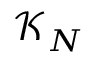<formula> <loc_0><loc_0><loc_500><loc_500>\mathcal { K } _ { N }</formula> 